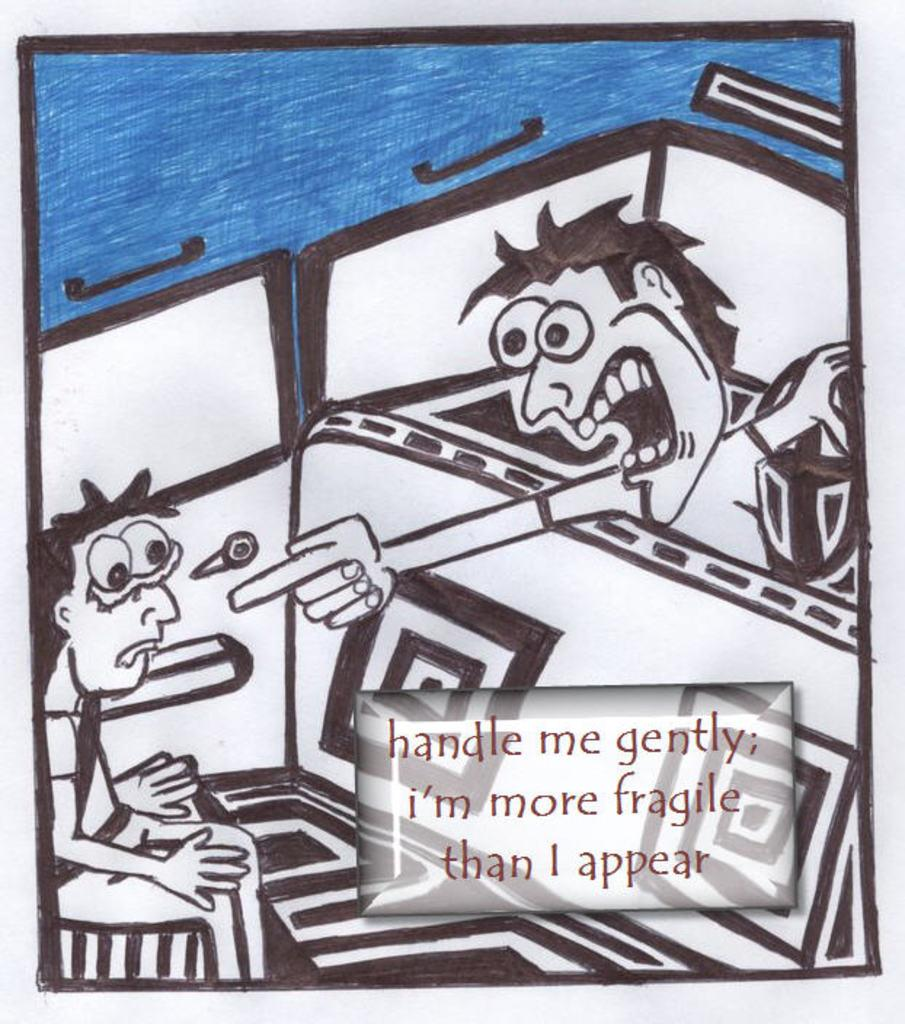<image>
Offer a succinct explanation of the picture presented. A cartoon man scolding another guy and saying he's fragile 